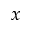Convert formula to latex. <formula><loc_0><loc_0><loc_500><loc_500>x</formula> 